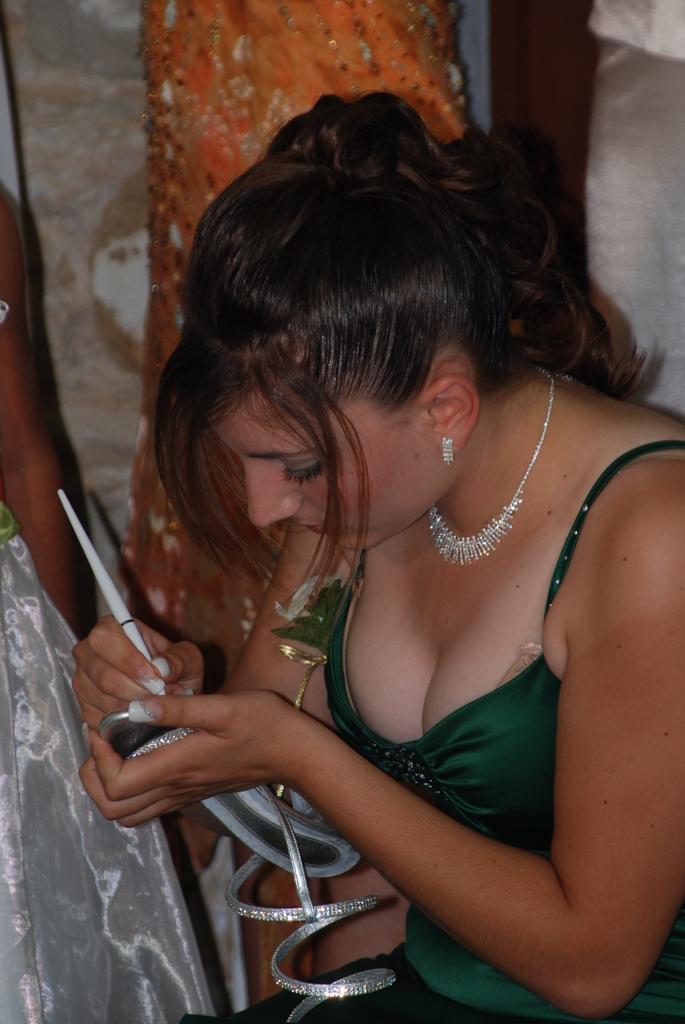Could you give a brief overview of what you see in this image? In this image we can see a woman writing something on the chappal in her hands. In the background we can see wall. 